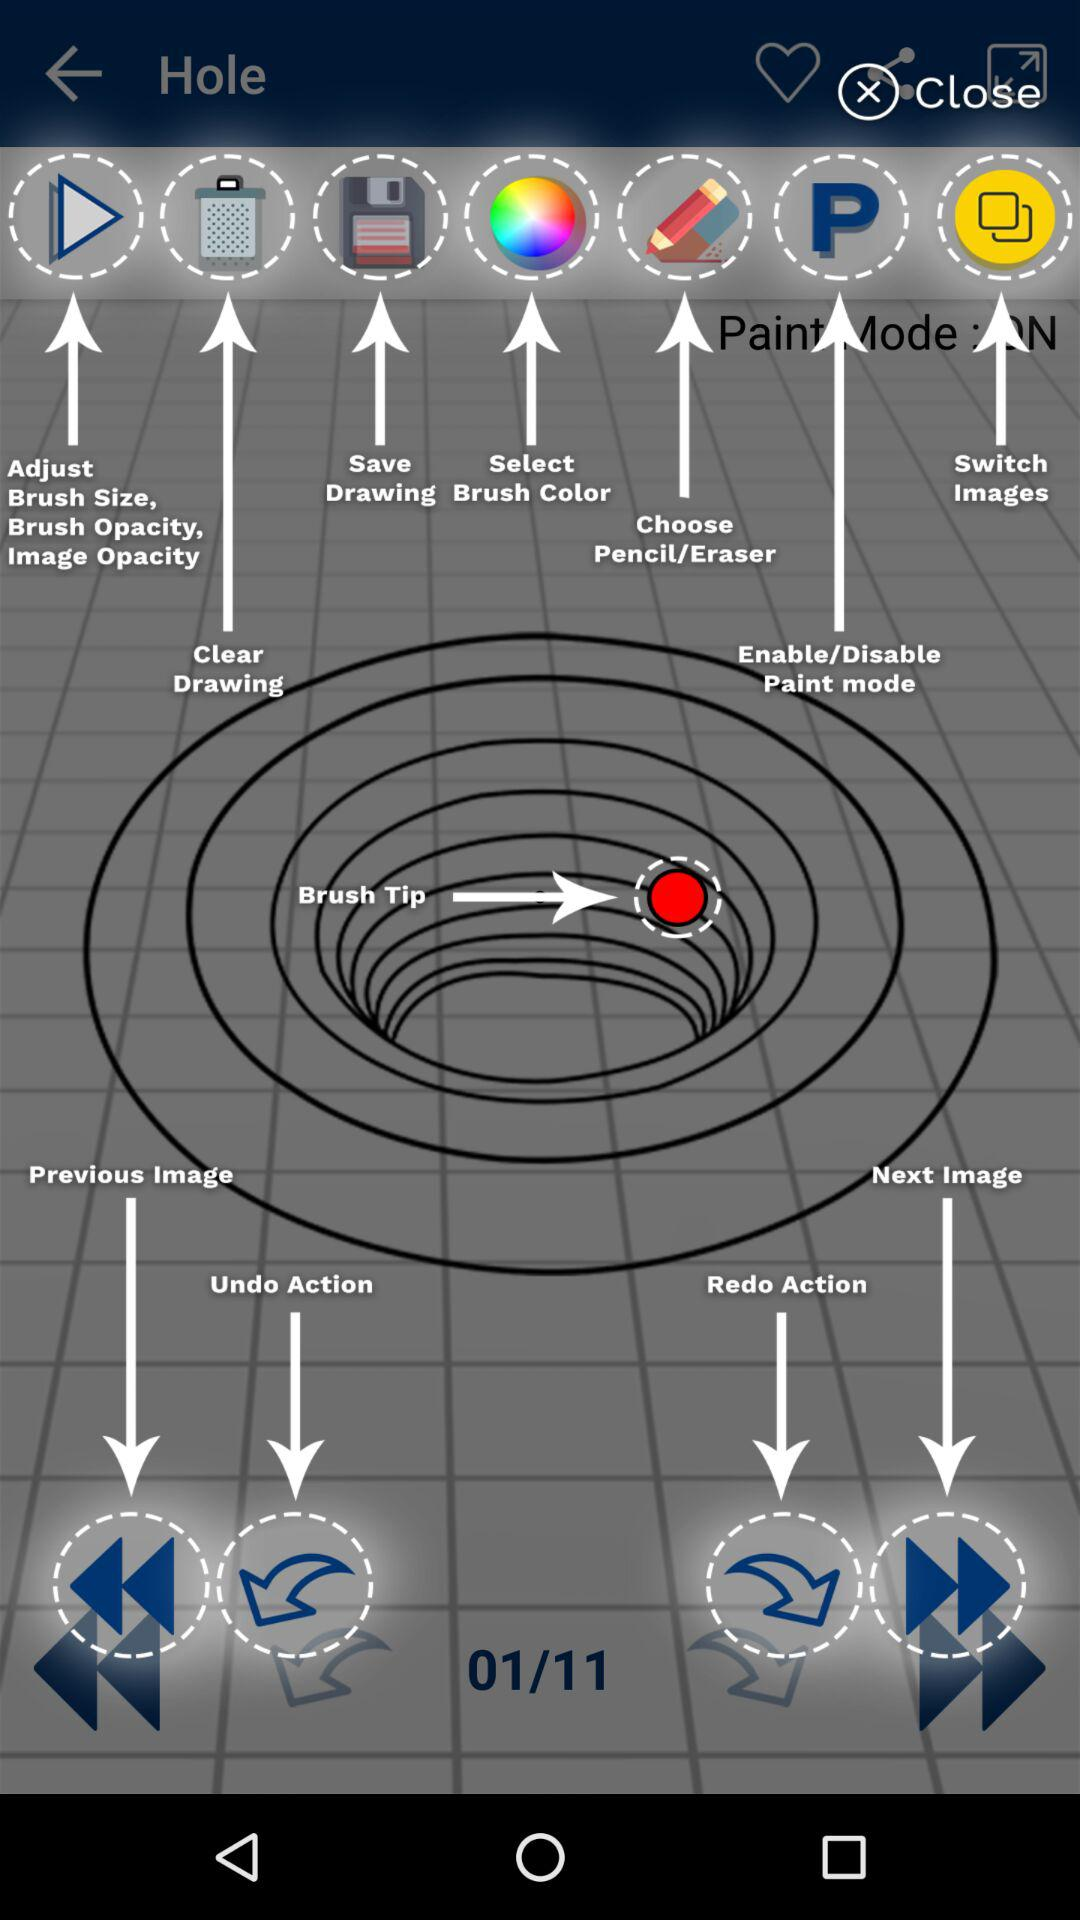How many functions in total are there? There are 11 functions. 